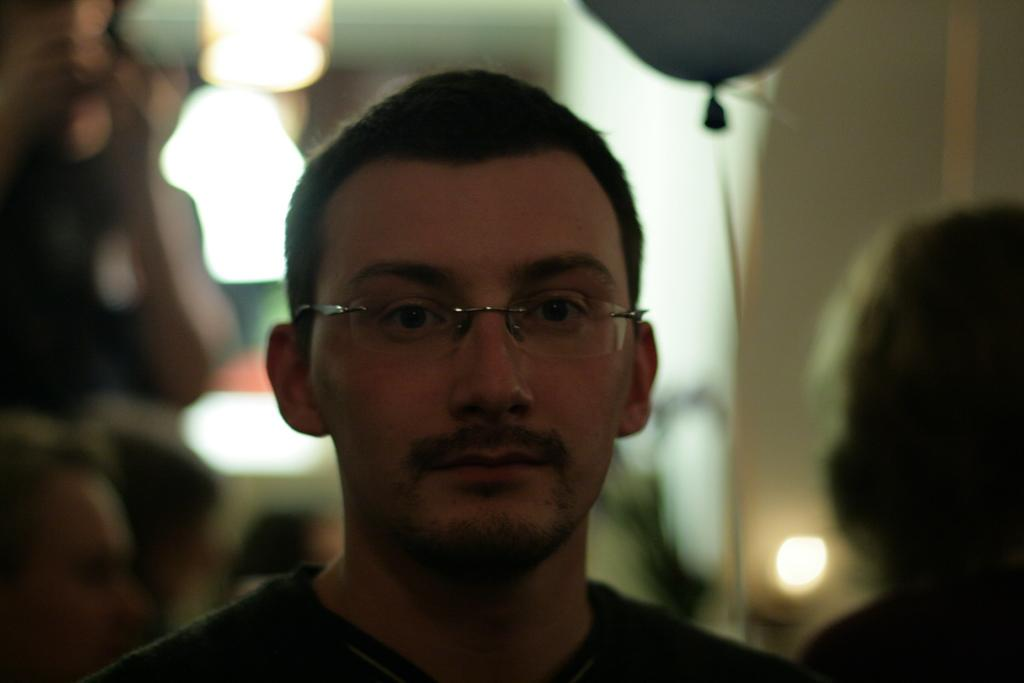What is the person in the foreground of the image wearing? The person in the image is wearing spectacles. Can you describe the background of the image? There are people visible in the background of the image. What type of equipment is present in the image? Focusing lights are present in the image. How many cats are visible in the image? There are no cats present in the image. Are there any fairies visible in the image? There are no fairies present in the image. 